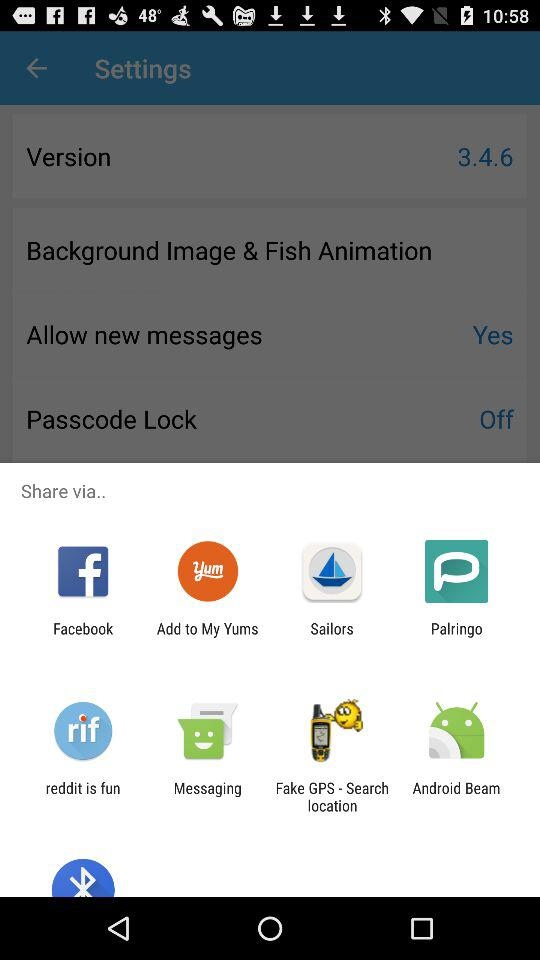Through which app can we share? You can share through "Facebook", "Add to My Yums", "Sailors", "Palringo", "reddit is fun", "Messaging", "Fake GPS - Search location" and "Bluetooth". 